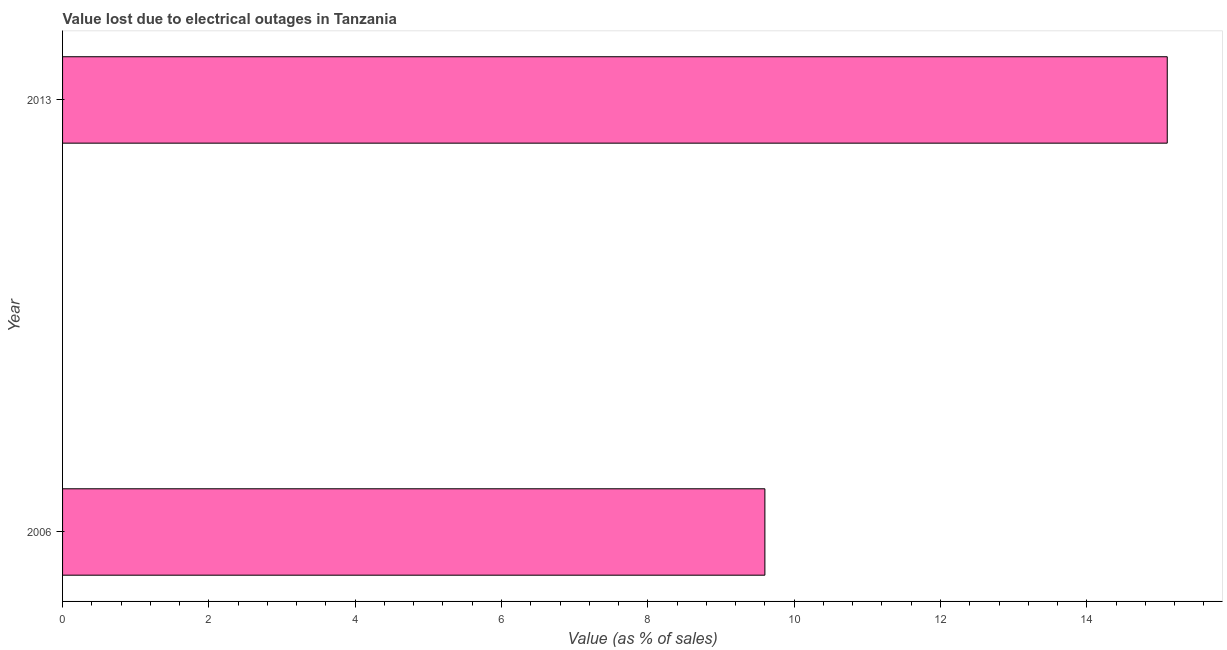Does the graph contain any zero values?
Give a very brief answer. No. What is the title of the graph?
Provide a succinct answer. Value lost due to electrical outages in Tanzania. What is the label or title of the X-axis?
Your answer should be compact. Value (as % of sales). What is the label or title of the Y-axis?
Provide a short and direct response. Year. What is the value lost due to electrical outages in 2013?
Offer a very short reply. 15.1. Across all years, what is the maximum value lost due to electrical outages?
Your response must be concise. 15.1. Across all years, what is the minimum value lost due to electrical outages?
Provide a short and direct response. 9.6. What is the sum of the value lost due to electrical outages?
Ensure brevity in your answer.  24.7. What is the difference between the value lost due to electrical outages in 2006 and 2013?
Keep it short and to the point. -5.5. What is the average value lost due to electrical outages per year?
Offer a very short reply. 12.35. What is the median value lost due to electrical outages?
Provide a short and direct response. 12.35. What is the ratio of the value lost due to electrical outages in 2006 to that in 2013?
Offer a very short reply. 0.64. In how many years, is the value lost due to electrical outages greater than the average value lost due to electrical outages taken over all years?
Provide a succinct answer. 1. How many bars are there?
Your answer should be very brief. 2. What is the difference between two consecutive major ticks on the X-axis?
Give a very brief answer. 2. Are the values on the major ticks of X-axis written in scientific E-notation?
Provide a succinct answer. No. What is the Value (as % of sales) in 2006?
Offer a terse response. 9.6. What is the difference between the Value (as % of sales) in 2006 and 2013?
Keep it short and to the point. -5.5. What is the ratio of the Value (as % of sales) in 2006 to that in 2013?
Your answer should be compact. 0.64. 